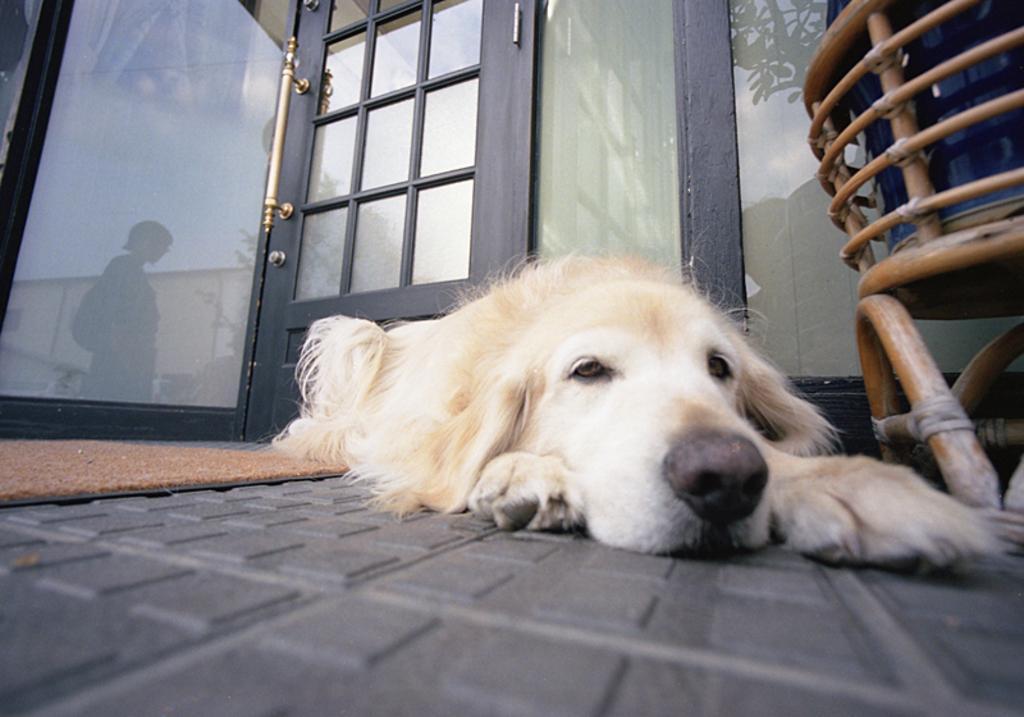Describe this image in one or two sentences. This picture is clicked inside the room. In the right corner we can see a wooden object containing some item. In the center we can see a dog lying on the ground. On the left we can see the mat. In the background we can see the door and we can see the reflection of a person and the reflections of some other objects on the glasses. 